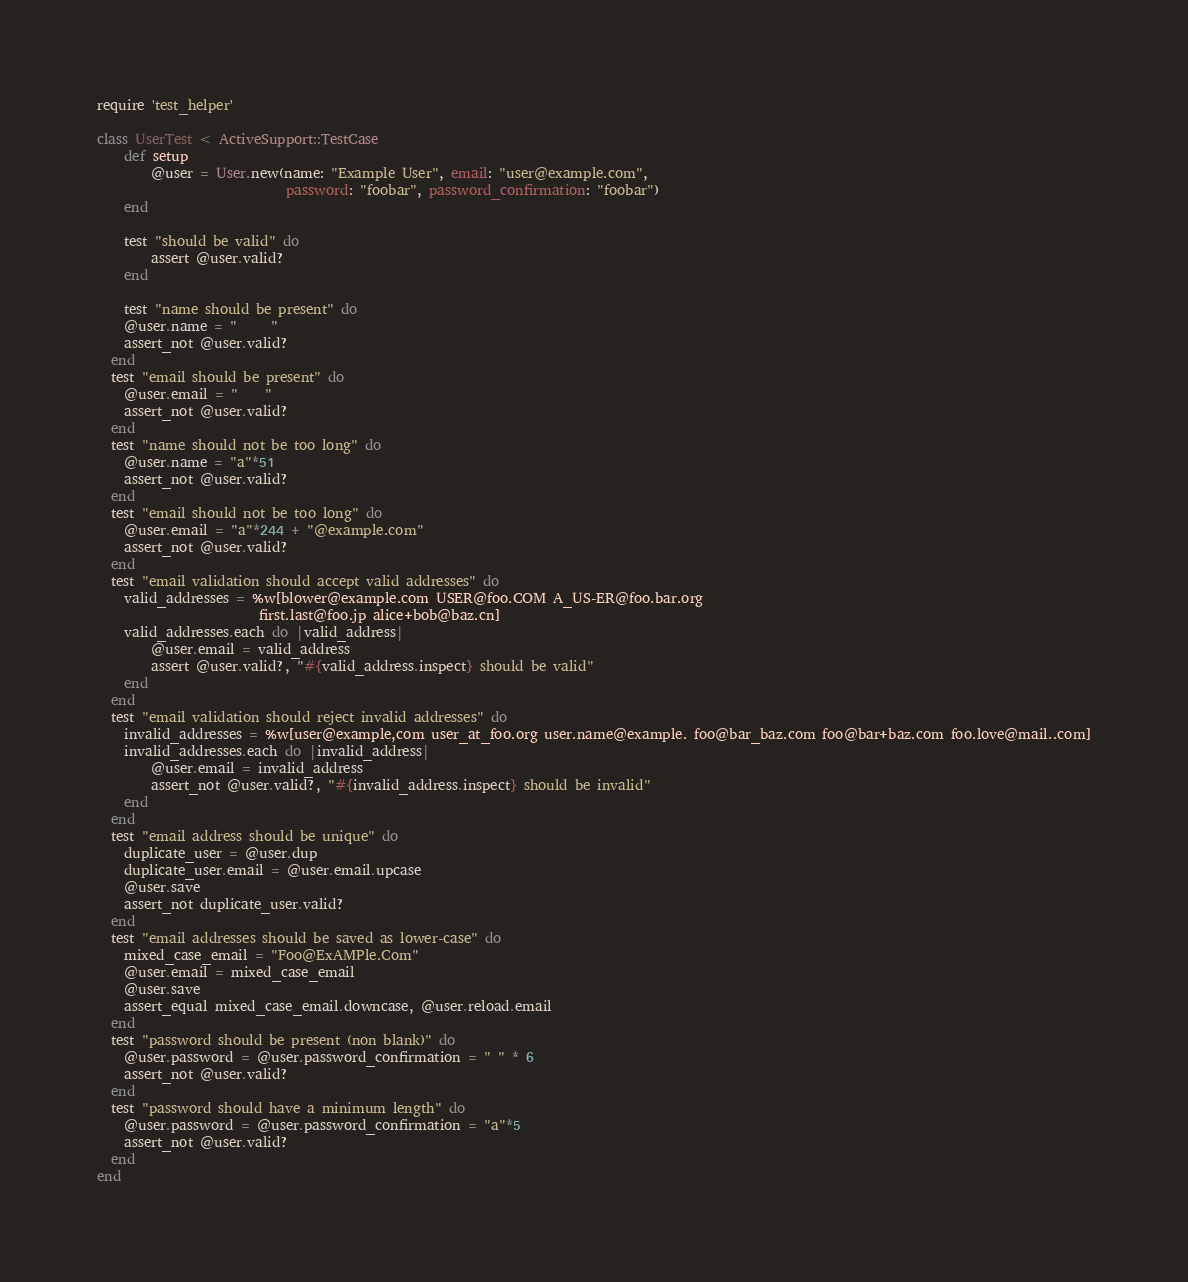Convert code to text. <code><loc_0><loc_0><loc_500><loc_500><_Ruby_>require 'test_helper'

class UserTest < ActiveSupport::TestCase
	def setup
		@user = User.new(name: "Example User", email: "user@example.com",
							password: "foobar", password_confirmation: "foobar")
	end

	test "should be valid" do
		assert @user.valid?
	end

	test "name should be present" do
    @user.name = "     "
    assert_not @user.valid?
  end
  test "email should be present" do
  	@user.email = "    "
  	assert_not @user.valid?
  end
  test "name should not be too long" do
  	@user.name = "a"*51
  	assert_not @user.valid?
  end
  test "email should not be too long" do
  	@user.email = "a"*244 + "@example.com"
  	assert_not @user.valid?
  end
  test "email validation should accept valid addresses" do 
  	valid_addresses = %w[blower@example.com USER@foo.COM A_US-ER@foo.bar.org
  						first.last@foo.jp alice+bob@baz.cn]
  	valid_addresses.each do |valid_address|
  		@user.email = valid_address
  		assert @user.valid?, "#{valid_address.inspect} should be valid"
  	end
  end
  test "email validation should reject invalid addresses" do
  	invalid_addresses = %w[user@example,com user_at_foo.org user.name@example. foo@bar_baz.com foo@bar+baz.com foo.love@mail..com]
  	invalid_addresses.each do |invalid_address|
  		@user.email = invalid_address
  		assert_not @user.valid?, "#{invalid_address.inspect} should be invalid"
  	end
  end
  test "email address should be unique" do
  	duplicate_user = @user.dup
  	duplicate_user.email = @user.email.upcase
  	@user.save
  	assert_not duplicate_user.valid?
  end
  test "email addresses should be saved as lower-case" do
  	mixed_case_email = "Foo@ExAMPle.Com"
  	@user.email = mixed_case_email
  	@user.save
  	assert_equal mixed_case_email.downcase, @user.reload.email
  end
  test "password should be present (non blank)" do
  	@user.password = @user.password_confirmation = " " * 6
  	assert_not @user.valid?
  end
  test "password should have a minimum length" do
  	@user.password = @user.password_confirmation = "a"*5
  	assert_not @user.valid?
  end
end
</code> 